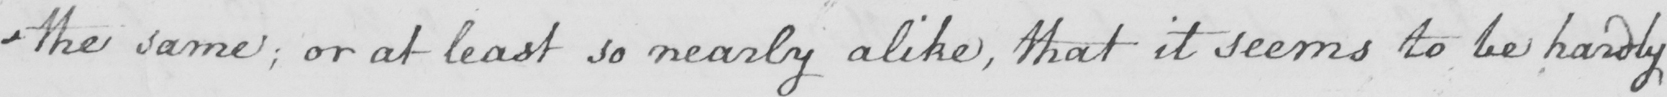Please provide the text content of this handwritten line. - the same  ; or at least so nearly alike  , that it seems to be hardly 